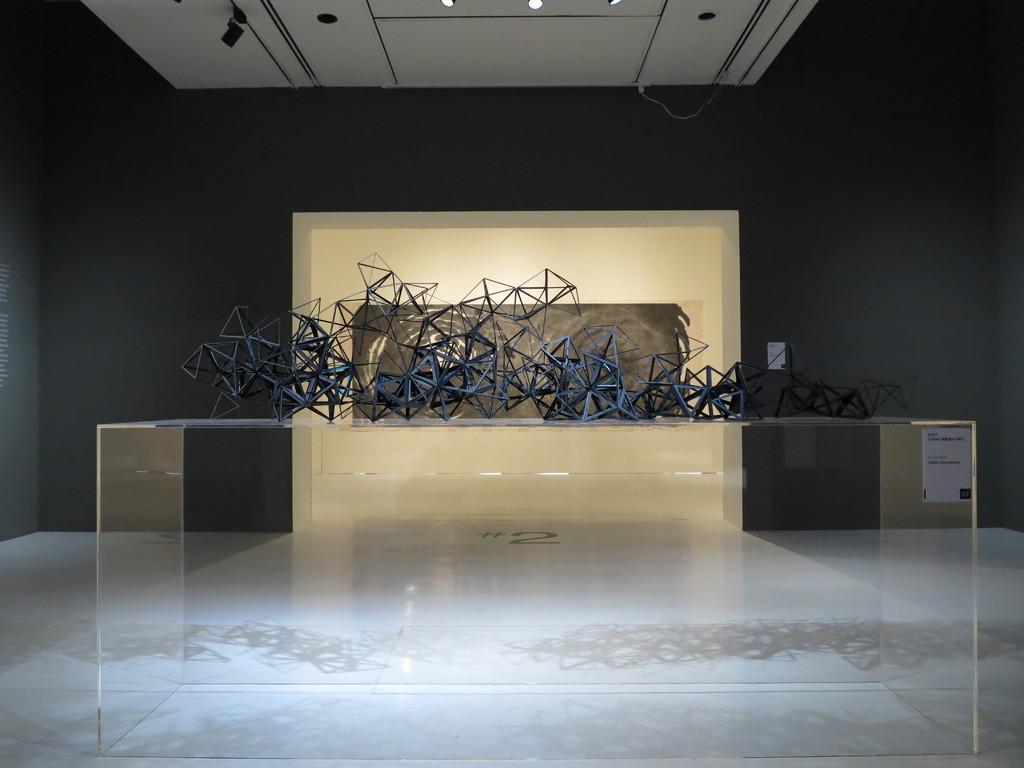In one or two sentences, can you explain what this image depicts? In this image there are few objects placed on a glass table. In the background there is a wall. At the top of the image there is a ceiling with lights. 